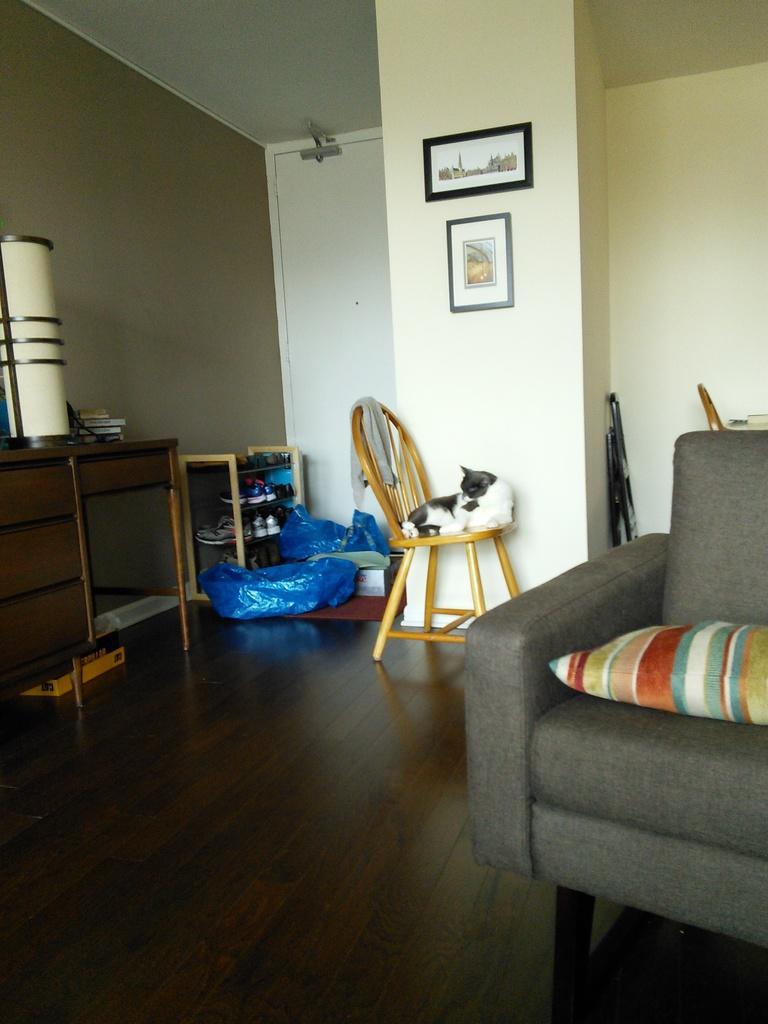How would you summarize this image in a sentence or two? In this picture we can see a grey chair and a multi color pillow. There is a cat on the chair and a cloth. Two frames are seen on the wall. There is a blue cover and many shoes are kept in a shoe rack to the corner. There are books and white object on the desk. There is a yellow box is kept under the desk. A white door is seen. 